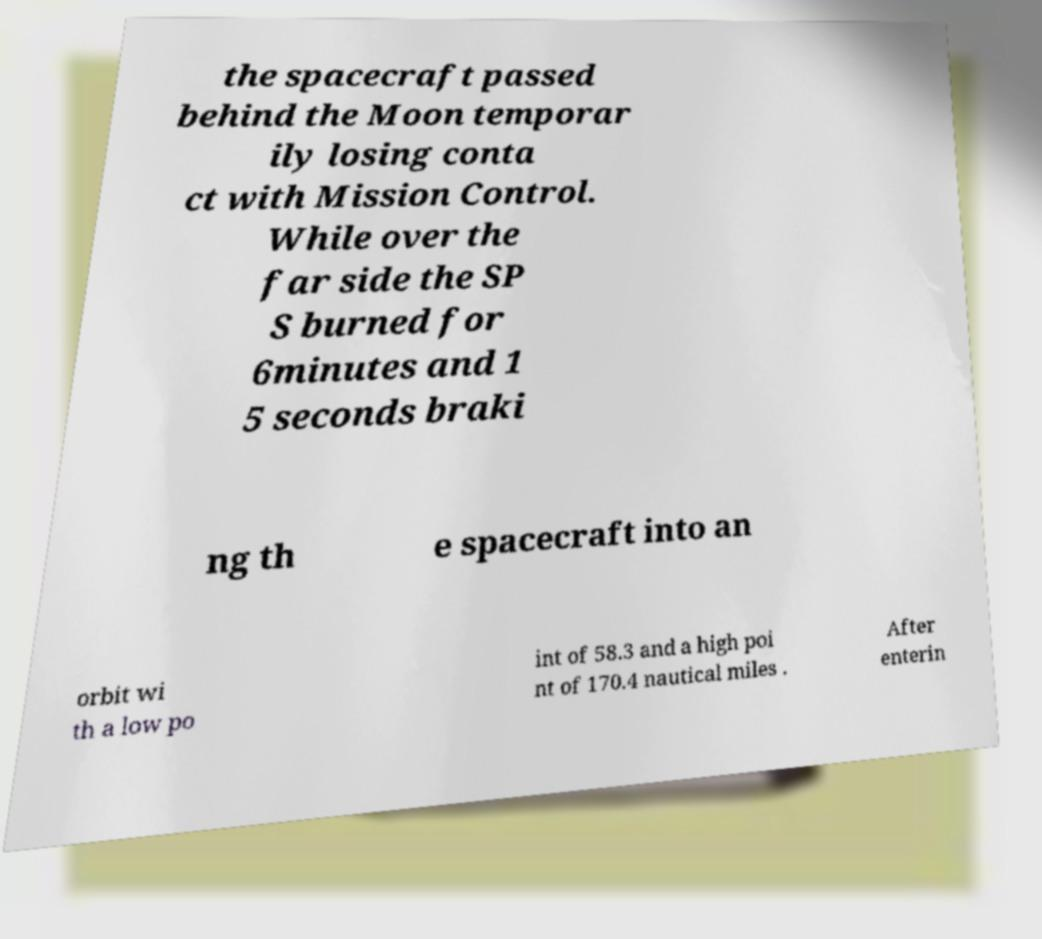For documentation purposes, I need the text within this image transcribed. Could you provide that? the spacecraft passed behind the Moon temporar ily losing conta ct with Mission Control. While over the far side the SP S burned for 6minutes and 1 5 seconds braki ng th e spacecraft into an orbit wi th a low po int of 58.3 and a high poi nt of 170.4 nautical miles . After enterin 